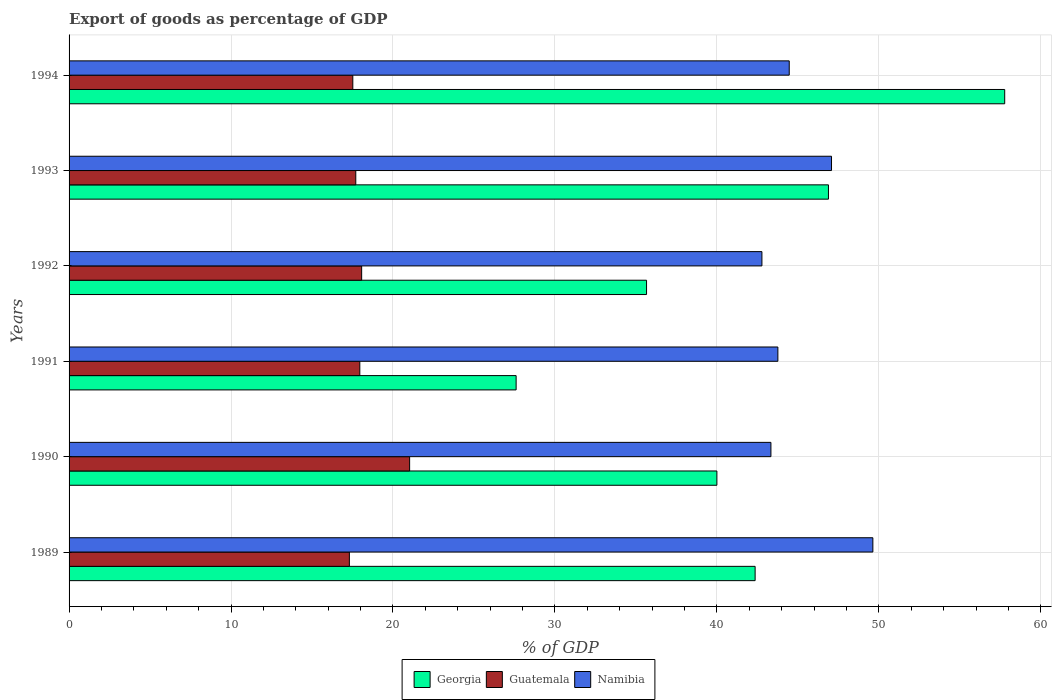How many different coloured bars are there?
Make the answer very short. 3. How many bars are there on the 3rd tick from the bottom?
Provide a short and direct response. 3. What is the label of the 2nd group of bars from the top?
Your answer should be very brief. 1993. What is the export of goods as percentage of GDP in Guatemala in 1993?
Your response must be concise. 17.7. Across all years, what is the maximum export of goods as percentage of GDP in Georgia?
Offer a very short reply. 57.77. Across all years, what is the minimum export of goods as percentage of GDP in Georgia?
Offer a terse response. 27.6. In which year was the export of goods as percentage of GDP in Georgia minimum?
Provide a succinct answer. 1991. What is the total export of goods as percentage of GDP in Georgia in the graph?
Offer a terse response. 250.28. What is the difference between the export of goods as percentage of GDP in Namibia in 1990 and that in 1993?
Ensure brevity in your answer.  -3.74. What is the difference between the export of goods as percentage of GDP in Namibia in 1990 and the export of goods as percentage of GDP in Georgia in 1994?
Your answer should be very brief. -14.44. What is the average export of goods as percentage of GDP in Guatemala per year?
Keep it short and to the point. 18.26. In the year 1993, what is the difference between the export of goods as percentage of GDP in Namibia and export of goods as percentage of GDP in Georgia?
Offer a terse response. 0.19. What is the ratio of the export of goods as percentage of GDP in Georgia in 1990 to that in 1993?
Provide a succinct answer. 0.85. What is the difference between the highest and the second highest export of goods as percentage of GDP in Namibia?
Your answer should be very brief. 2.55. What is the difference between the highest and the lowest export of goods as percentage of GDP in Namibia?
Offer a very short reply. 6.85. In how many years, is the export of goods as percentage of GDP in Georgia greater than the average export of goods as percentage of GDP in Georgia taken over all years?
Your answer should be compact. 3. What does the 1st bar from the top in 1990 represents?
Your answer should be compact. Namibia. What does the 1st bar from the bottom in 1992 represents?
Offer a very short reply. Georgia. How many bars are there?
Your answer should be compact. 18. Are all the bars in the graph horizontal?
Your answer should be very brief. Yes. How many years are there in the graph?
Give a very brief answer. 6. Does the graph contain any zero values?
Make the answer very short. No. Does the graph contain grids?
Make the answer very short. Yes. How many legend labels are there?
Provide a short and direct response. 3. How are the legend labels stacked?
Your response must be concise. Horizontal. What is the title of the graph?
Your answer should be compact. Export of goods as percentage of GDP. Does "Georgia" appear as one of the legend labels in the graph?
Provide a short and direct response. Yes. What is the label or title of the X-axis?
Your answer should be very brief. % of GDP. What is the label or title of the Y-axis?
Keep it short and to the point. Years. What is the % of GDP of Georgia in 1989?
Offer a terse response. 42.36. What is the % of GDP of Guatemala in 1989?
Your response must be concise. 17.31. What is the % of GDP in Namibia in 1989?
Keep it short and to the point. 49.63. What is the % of GDP in Georgia in 1990?
Make the answer very short. 40. What is the % of GDP in Guatemala in 1990?
Offer a very short reply. 21.03. What is the % of GDP of Namibia in 1990?
Your answer should be compact. 43.34. What is the % of GDP in Georgia in 1991?
Your answer should be very brief. 27.6. What is the % of GDP of Guatemala in 1991?
Your response must be concise. 17.95. What is the % of GDP of Namibia in 1991?
Provide a succinct answer. 43.77. What is the % of GDP in Georgia in 1992?
Provide a short and direct response. 35.66. What is the % of GDP of Guatemala in 1992?
Your answer should be very brief. 18.07. What is the % of GDP in Namibia in 1992?
Your response must be concise. 42.78. What is the % of GDP of Georgia in 1993?
Keep it short and to the point. 46.89. What is the % of GDP of Guatemala in 1993?
Ensure brevity in your answer.  17.7. What is the % of GDP of Namibia in 1993?
Keep it short and to the point. 47.08. What is the % of GDP in Georgia in 1994?
Make the answer very short. 57.77. What is the % of GDP in Guatemala in 1994?
Your response must be concise. 17.52. What is the % of GDP in Namibia in 1994?
Make the answer very short. 44.47. Across all years, what is the maximum % of GDP in Georgia?
Make the answer very short. 57.77. Across all years, what is the maximum % of GDP in Guatemala?
Provide a succinct answer. 21.03. Across all years, what is the maximum % of GDP in Namibia?
Make the answer very short. 49.63. Across all years, what is the minimum % of GDP in Georgia?
Provide a succinct answer. 27.6. Across all years, what is the minimum % of GDP of Guatemala?
Provide a succinct answer. 17.31. Across all years, what is the minimum % of GDP of Namibia?
Offer a terse response. 42.78. What is the total % of GDP of Georgia in the graph?
Ensure brevity in your answer.  250.28. What is the total % of GDP in Guatemala in the graph?
Your answer should be compact. 109.58. What is the total % of GDP of Namibia in the graph?
Make the answer very short. 271.06. What is the difference between the % of GDP of Georgia in 1989 and that in 1990?
Your response must be concise. 2.36. What is the difference between the % of GDP in Guatemala in 1989 and that in 1990?
Provide a short and direct response. -3.72. What is the difference between the % of GDP of Namibia in 1989 and that in 1990?
Your answer should be very brief. 6.29. What is the difference between the % of GDP in Georgia in 1989 and that in 1991?
Your response must be concise. 14.76. What is the difference between the % of GDP in Guatemala in 1989 and that in 1991?
Provide a short and direct response. -0.65. What is the difference between the % of GDP in Namibia in 1989 and that in 1991?
Ensure brevity in your answer.  5.87. What is the difference between the % of GDP of Georgia in 1989 and that in 1992?
Make the answer very short. 6.7. What is the difference between the % of GDP of Guatemala in 1989 and that in 1992?
Your answer should be very brief. -0.76. What is the difference between the % of GDP of Namibia in 1989 and that in 1992?
Provide a succinct answer. 6.85. What is the difference between the % of GDP in Georgia in 1989 and that in 1993?
Give a very brief answer. -4.53. What is the difference between the % of GDP in Guatemala in 1989 and that in 1993?
Your response must be concise. -0.4. What is the difference between the % of GDP in Namibia in 1989 and that in 1993?
Provide a succinct answer. 2.55. What is the difference between the % of GDP of Georgia in 1989 and that in 1994?
Offer a very short reply. -15.41. What is the difference between the % of GDP of Guatemala in 1989 and that in 1994?
Your answer should be very brief. -0.21. What is the difference between the % of GDP of Namibia in 1989 and that in 1994?
Give a very brief answer. 5.16. What is the difference between the % of GDP of Georgia in 1990 and that in 1991?
Your response must be concise. 12.4. What is the difference between the % of GDP of Guatemala in 1990 and that in 1991?
Keep it short and to the point. 3.07. What is the difference between the % of GDP of Namibia in 1990 and that in 1991?
Your answer should be compact. -0.43. What is the difference between the % of GDP of Georgia in 1990 and that in 1992?
Provide a succinct answer. 4.34. What is the difference between the % of GDP of Guatemala in 1990 and that in 1992?
Your answer should be compact. 2.96. What is the difference between the % of GDP in Namibia in 1990 and that in 1992?
Offer a very short reply. 0.56. What is the difference between the % of GDP of Georgia in 1990 and that in 1993?
Provide a succinct answer. -6.89. What is the difference between the % of GDP of Guatemala in 1990 and that in 1993?
Keep it short and to the point. 3.32. What is the difference between the % of GDP in Namibia in 1990 and that in 1993?
Offer a very short reply. -3.74. What is the difference between the % of GDP of Georgia in 1990 and that in 1994?
Keep it short and to the point. -17.77. What is the difference between the % of GDP in Guatemala in 1990 and that in 1994?
Provide a succinct answer. 3.51. What is the difference between the % of GDP in Namibia in 1990 and that in 1994?
Provide a succinct answer. -1.13. What is the difference between the % of GDP of Georgia in 1991 and that in 1992?
Make the answer very short. -8.05. What is the difference between the % of GDP in Guatemala in 1991 and that in 1992?
Ensure brevity in your answer.  -0.11. What is the difference between the % of GDP of Georgia in 1991 and that in 1993?
Your response must be concise. -19.28. What is the difference between the % of GDP in Guatemala in 1991 and that in 1993?
Give a very brief answer. 0.25. What is the difference between the % of GDP of Namibia in 1991 and that in 1993?
Your answer should be very brief. -3.31. What is the difference between the % of GDP of Georgia in 1991 and that in 1994?
Give a very brief answer. -30.17. What is the difference between the % of GDP in Guatemala in 1991 and that in 1994?
Keep it short and to the point. 0.43. What is the difference between the % of GDP of Namibia in 1991 and that in 1994?
Your answer should be compact. -0.7. What is the difference between the % of GDP in Georgia in 1992 and that in 1993?
Your answer should be compact. -11.23. What is the difference between the % of GDP of Guatemala in 1992 and that in 1993?
Keep it short and to the point. 0.36. What is the difference between the % of GDP of Namibia in 1992 and that in 1993?
Offer a very short reply. -4.3. What is the difference between the % of GDP of Georgia in 1992 and that in 1994?
Keep it short and to the point. -22.12. What is the difference between the % of GDP in Guatemala in 1992 and that in 1994?
Provide a succinct answer. 0.55. What is the difference between the % of GDP in Namibia in 1992 and that in 1994?
Provide a succinct answer. -1.69. What is the difference between the % of GDP in Georgia in 1993 and that in 1994?
Make the answer very short. -10.88. What is the difference between the % of GDP of Guatemala in 1993 and that in 1994?
Offer a terse response. 0.18. What is the difference between the % of GDP of Namibia in 1993 and that in 1994?
Provide a short and direct response. 2.61. What is the difference between the % of GDP in Georgia in 1989 and the % of GDP in Guatemala in 1990?
Offer a very short reply. 21.33. What is the difference between the % of GDP of Georgia in 1989 and the % of GDP of Namibia in 1990?
Your answer should be very brief. -0.98. What is the difference between the % of GDP in Guatemala in 1989 and the % of GDP in Namibia in 1990?
Give a very brief answer. -26.03. What is the difference between the % of GDP in Georgia in 1989 and the % of GDP in Guatemala in 1991?
Your answer should be very brief. 24.41. What is the difference between the % of GDP in Georgia in 1989 and the % of GDP in Namibia in 1991?
Provide a short and direct response. -1.4. What is the difference between the % of GDP in Guatemala in 1989 and the % of GDP in Namibia in 1991?
Offer a very short reply. -26.46. What is the difference between the % of GDP in Georgia in 1989 and the % of GDP in Guatemala in 1992?
Ensure brevity in your answer.  24.3. What is the difference between the % of GDP in Georgia in 1989 and the % of GDP in Namibia in 1992?
Your answer should be compact. -0.42. What is the difference between the % of GDP of Guatemala in 1989 and the % of GDP of Namibia in 1992?
Offer a very short reply. -25.47. What is the difference between the % of GDP of Georgia in 1989 and the % of GDP of Guatemala in 1993?
Make the answer very short. 24.66. What is the difference between the % of GDP of Georgia in 1989 and the % of GDP of Namibia in 1993?
Keep it short and to the point. -4.72. What is the difference between the % of GDP in Guatemala in 1989 and the % of GDP in Namibia in 1993?
Keep it short and to the point. -29.77. What is the difference between the % of GDP of Georgia in 1989 and the % of GDP of Guatemala in 1994?
Offer a terse response. 24.84. What is the difference between the % of GDP in Georgia in 1989 and the % of GDP in Namibia in 1994?
Give a very brief answer. -2.11. What is the difference between the % of GDP in Guatemala in 1989 and the % of GDP in Namibia in 1994?
Keep it short and to the point. -27.16. What is the difference between the % of GDP of Georgia in 1990 and the % of GDP of Guatemala in 1991?
Your answer should be compact. 22.05. What is the difference between the % of GDP in Georgia in 1990 and the % of GDP in Namibia in 1991?
Give a very brief answer. -3.77. What is the difference between the % of GDP of Guatemala in 1990 and the % of GDP of Namibia in 1991?
Your answer should be very brief. -22.74. What is the difference between the % of GDP of Georgia in 1990 and the % of GDP of Guatemala in 1992?
Your answer should be very brief. 21.93. What is the difference between the % of GDP in Georgia in 1990 and the % of GDP in Namibia in 1992?
Your answer should be very brief. -2.78. What is the difference between the % of GDP of Guatemala in 1990 and the % of GDP of Namibia in 1992?
Make the answer very short. -21.75. What is the difference between the % of GDP in Georgia in 1990 and the % of GDP in Guatemala in 1993?
Offer a terse response. 22.3. What is the difference between the % of GDP in Georgia in 1990 and the % of GDP in Namibia in 1993?
Provide a short and direct response. -7.08. What is the difference between the % of GDP in Guatemala in 1990 and the % of GDP in Namibia in 1993?
Provide a short and direct response. -26.05. What is the difference between the % of GDP of Georgia in 1990 and the % of GDP of Guatemala in 1994?
Your response must be concise. 22.48. What is the difference between the % of GDP of Georgia in 1990 and the % of GDP of Namibia in 1994?
Your answer should be compact. -4.47. What is the difference between the % of GDP of Guatemala in 1990 and the % of GDP of Namibia in 1994?
Your answer should be compact. -23.44. What is the difference between the % of GDP in Georgia in 1991 and the % of GDP in Guatemala in 1992?
Keep it short and to the point. 9.54. What is the difference between the % of GDP of Georgia in 1991 and the % of GDP of Namibia in 1992?
Offer a very short reply. -15.18. What is the difference between the % of GDP in Guatemala in 1991 and the % of GDP in Namibia in 1992?
Provide a short and direct response. -24.83. What is the difference between the % of GDP in Georgia in 1991 and the % of GDP in Guatemala in 1993?
Give a very brief answer. 9.9. What is the difference between the % of GDP of Georgia in 1991 and the % of GDP of Namibia in 1993?
Offer a terse response. -19.47. What is the difference between the % of GDP of Guatemala in 1991 and the % of GDP of Namibia in 1993?
Offer a very short reply. -29.13. What is the difference between the % of GDP in Georgia in 1991 and the % of GDP in Guatemala in 1994?
Offer a very short reply. 10.08. What is the difference between the % of GDP of Georgia in 1991 and the % of GDP of Namibia in 1994?
Provide a short and direct response. -16.86. What is the difference between the % of GDP in Guatemala in 1991 and the % of GDP in Namibia in 1994?
Keep it short and to the point. -26.52. What is the difference between the % of GDP in Georgia in 1992 and the % of GDP in Guatemala in 1993?
Offer a terse response. 17.95. What is the difference between the % of GDP of Georgia in 1992 and the % of GDP of Namibia in 1993?
Offer a very short reply. -11.42. What is the difference between the % of GDP of Guatemala in 1992 and the % of GDP of Namibia in 1993?
Offer a terse response. -29.01. What is the difference between the % of GDP of Georgia in 1992 and the % of GDP of Guatemala in 1994?
Give a very brief answer. 18.14. What is the difference between the % of GDP in Georgia in 1992 and the % of GDP in Namibia in 1994?
Make the answer very short. -8.81. What is the difference between the % of GDP of Guatemala in 1992 and the % of GDP of Namibia in 1994?
Your response must be concise. -26.4. What is the difference between the % of GDP of Georgia in 1993 and the % of GDP of Guatemala in 1994?
Give a very brief answer. 29.37. What is the difference between the % of GDP in Georgia in 1993 and the % of GDP in Namibia in 1994?
Provide a succinct answer. 2.42. What is the difference between the % of GDP in Guatemala in 1993 and the % of GDP in Namibia in 1994?
Offer a very short reply. -26.76. What is the average % of GDP in Georgia per year?
Offer a terse response. 41.71. What is the average % of GDP in Guatemala per year?
Your response must be concise. 18.26. What is the average % of GDP in Namibia per year?
Give a very brief answer. 45.18. In the year 1989, what is the difference between the % of GDP of Georgia and % of GDP of Guatemala?
Offer a very short reply. 25.05. In the year 1989, what is the difference between the % of GDP in Georgia and % of GDP in Namibia?
Offer a very short reply. -7.27. In the year 1989, what is the difference between the % of GDP of Guatemala and % of GDP of Namibia?
Your answer should be compact. -32.32. In the year 1990, what is the difference between the % of GDP of Georgia and % of GDP of Guatemala?
Keep it short and to the point. 18.97. In the year 1990, what is the difference between the % of GDP of Georgia and % of GDP of Namibia?
Provide a short and direct response. -3.34. In the year 1990, what is the difference between the % of GDP in Guatemala and % of GDP in Namibia?
Provide a succinct answer. -22.31. In the year 1991, what is the difference between the % of GDP of Georgia and % of GDP of Guatemala?
Your answer should be very brief. 9.65. In the year 1991, what is the difference between the % of GDP of Georgia and % of GDP of Namibia?
Keep it short and to the point. -16.16. In the year 1991, what is the difference between the % of GDP of Guatemala and % of GDP of Namibia?
Your answer should be compact. -25.81. In the year 1992, what is the difference between the % of GDP of Georgia and % of GDP of Guatemala?
Offer a terse response. 17.59. In the year 1992, what is the difference between the % of GDP in Georgia and % of GDP in Namibia?
Your answer should be very brief. -7.12. In the year 1992, what is the difference between the % of GDP of Guatemala and % of GDP of Namibia?
Offer a terse response. -24.71. In the year 1993, what is the difference between the % of GDP of Georgia and % of GDP of Guatemala?
Ensure brevity in your answer.  29.19. In the year 1993, what is the difference between the % of GDP in Georgia and % of GDP in Namibia?
Ensure brevity in your answer.  -0.19. In the year 1993, what is the difference between the % of GDP of Guatemala and % of GDP of Namibia?
Provide a succinct answer. -29.37. In the year 1994, what is the difference between the % of GDP of Georgia and % of GDP of Guatemala?
Ensure brevity in your answer.  40.25. In the year 1994, what is the difference between the % of GDP of Georgia and % of GDP of Namibia?
Provide a short and direct response. 13.3. In the year 1994, what is the difference between the % of GDP in Guatemala and % of GDP in Namibia?
Give a very brief answer. -26.95. What is the ratio of the % of GDP of Georgia in 1989 to that in 1990?
Make the answer very short. 1.06. What is the ratio of the % of GDP in Guatemala in 1989 to that in 1990?
Make the answer very short. 0.82. What is the ratio of the % of GDP of Namibia in 1989 to that in 1990?
Provide a succinct answer. 1.15. What is the ratio of the % of GDP of Georgia in 1989 to that in 1991?
Provide a succinct answer. 1.53. What is the ratio of the % of GDP of Guatemala in 1989 to that in 1991?
Offer a very short reply. 0.96. What is the ratio of the % of GDP of Namibia in 1989 to that in 1991?
Offer a very short reply. 1.13. What is the ratio of the % of GDP of Georgia in 1989 to that in 1992?
Offer a very short reply. 1.19. What is the ratio of the % of GDP in Guatemala in 1989 to that in 1992?
Provide a succinct answer. 0.96. What is the ratio of the % of GDP in Namibia in 1989 to that in 1992?
Ensure brevity in your answer.  1.16. What is the ratio of the % of GDP of Georgia in 1989 to that in 1993?
Give a very brief answer. 0.9. What is the ratio of the % of GDP in Guatemala in 1989 to that in 1993?
Offer a very short reply. 0.98. What is the ratio of the % of GDP of Namibia in 1989 to that in 1993?
Provide a short and direct response. 1.05. What is the ratio of the % of GDP of Georgia in 1989 to that in 1994?
Your answer should be compact. 0.73. What is the ratio of the % of GDP in Guatemala in 1989 to that in 1994?
Your answer should be very brief. 0.99. What is the ratio of the % of GDP of Namibia in 1989 to that in 1994?
Make the answer very short. 1.12. What is the ratio of the % of GDP of Georgia in 1990 to that in 1991?
Keep it short and to the point. 1.45. What is the ratio of the % of GDP in Guatemala in 1990 to that in 1991?
Your response must be concise. 1.17. What is the ratio of the % of GDP in Namibia in 1990 to that in 1991?
Keep it short and to the point. 0.99. What is the ratio of the % of GDP of Georgia in 1990 to that in 1992?
Provide a succinct answer. 1.12. What is the ratio of the % of GDP of Guatemala in 1990 to that in 1992?
Your answer should be compact. 1.16. What is the ratio of the % of GDP in Georgia in 1990 to that in 1993?
Provide a succinct answer. 0.85. What is the ratio of the % of GDP of Guatemala in 1990 to that in 1993?
Offer a very short reply. 1.19. What is the ratio of the % of GDP of Namibia in 1990 to that in 1993?
Provide a succinct answer. 0.92. What is the ratio of the % of GDP in Georgia in 1990 to that in 1994?
Your response must be concise. 0.69. What is the ratio of the % of GDP in Guatemala in 1990 to that in 1994?
Your answer should be very brief. 1.2. What is the ratio of the % of GDP in Namibia in 1990 to that in 1994?
Provide a succinct answer. 0.97. What is the ratio of the % of GDP of Georgia in 1991 to that in 1992?
Your response must be concise. 0.77. What is the ratio of the % of GDP of Guatemala in 1991 to that in 1992?
Keep it short and to the point. 0.99. What is the ratio of the % of GDP in Namibia in 1991 to that in 1992?
Your answer should be very brief. 1.02. What is the ratio of the % of GDP of Georgia in 1991 to that in 1993?
Give a very brief answer. 0.59. What is the ratio of the % of GDP in Guatemala in 1991 to that in 1993?
Offer a very short reply. 1.01. What is the ratio of the % of GDP in Namibia in 1991 to that in 1993?
Keep it short and to the point. 0.93. What is the ratio of the % of GDP in Georgia in 1991 to that in 1994?
Your response must be concise. 0.48. What is the ratio of the % of GDP in Guatemala in 1991 to that in 1994?
Your answer should be compact. 1.02. What is the ratio of the % of GDP of Namibia in 1991 to that in 1994?
Keep it short and to the point. 0.98. What is the ratio of the % of GDP of Georgia in 1992 to that in 1993?
Your answer should be very brief. 0.76. What is the ratio of the % of GDP in Guatemala in 1992 to that in 1993?
Your response must be concise. 1.02. What is the ratio of the % of GDP in Namibia in 1992 to that in 1993?
Your answer should be compact. 0.91. What is the ratio of the % of GDP of Georgia in 1992 to that in 1994?
Your response must be concise. 0.62. What is the ratio of the % of GDP in Guatemala in 1992 to that in 1994?
Keep it short and to the point. 1.03. What is the ratio of the % of GDP in Namibia in 1992 to that in 1994?
Offer a very short reply. 0.96. What is the ratio of the % of GDP of Georgia in 1993 to that in 1994?
Your answer should be compact. 0.81. What is the ratio of the % of GDP in Guatemala in 1993 to that in 1994?
Give a very brief answer. 1.01. What is the ratio of the % of GDP in Namibia in 1993 to that in 1994?
Keep it short and to the point. 1.06. What is the difference between the highest and the second highest % of GDP in Georgia?
Offer a terse response. 10.88. What is the difference between the highest and the second highest % of GDP in Guatemala?
Your response must be concise. 2.96. What is the difference between the highest and the second highest % of GDP of Namibia?
Provide a succinct answer. 2.55. What is the difference between the highest and the lowest % of GDP of Georgia?
Offer a very short reply. 30.17. What is the difference between the highest and the lowest % of GDP in Guatemala?
Your response must be concise. 3.72. What is the difference between the highest and the lowest % of GDP of Namibia?
Ensure brevity in your answer.  6.85. 